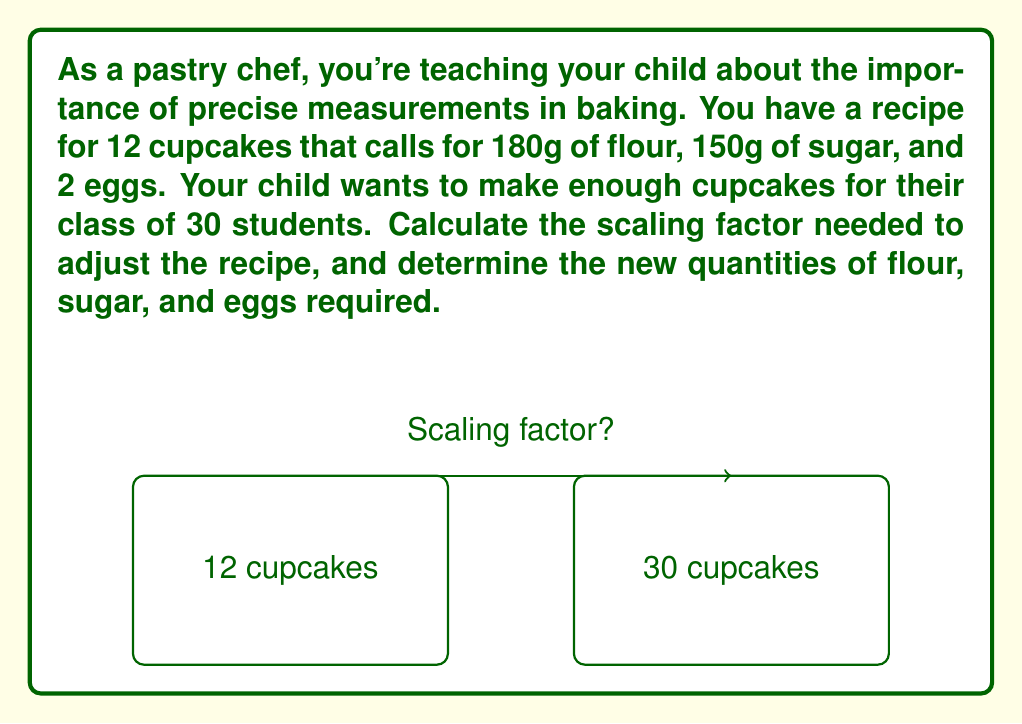Teach me how to tackle this problem. Let's approach this step-by-step:

1) First, we need to determine the scaling factor. This is the ratio of the desired number of cupcakes to the original number of cupcakes.

   Scaling factor = $\frac{\text{Desired number of cupcakes}}{\text{Original number of cupcakes}}$

   $$ \text{Scaling factor} = \frac{30}{12} = 2.5 $$

2) Now that we have the scaling factor, we can use it to adjust the quantities of each ingredient:

   For flour:
   $$ 180g \times 2.5 = 450g $$

   For sugar:
   $$ 150g \times 2.5 = 375g $$

   For eggs:
   $$ 2 \times 2.5 = 5 $$

3) Note that for eggs, we need to round to the nearest whole number, as we can't use a fraction of an egg. In this case, we would round up to 5 eggs.

This scaling method works because the relationship between ingredients and the number of cupcakes is linear. Doubling the ingredients doubles the output, tripling triples it, and so on. This is a fundamental concept in both baking and mathematics, demonstrating to your child how math is applied in real-world scenarios.
Answer: Scaling factor: 2.5; New quantities: 450g flour, 375g sugar, 5 eggs 